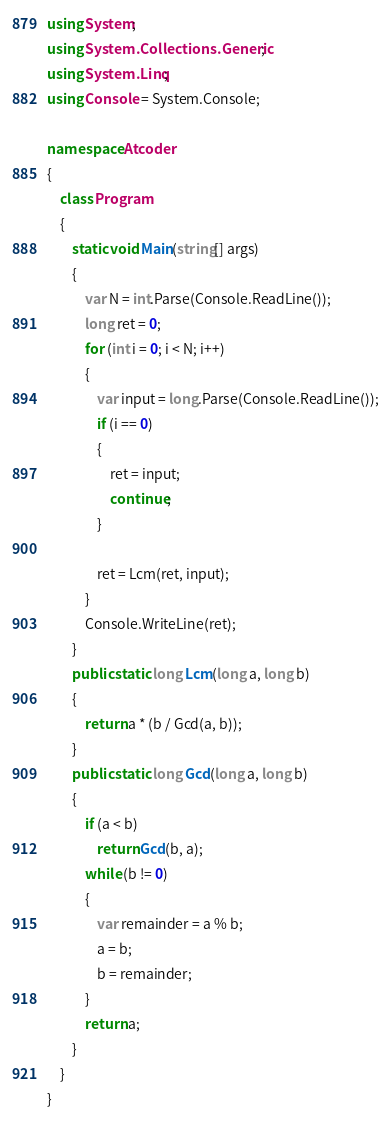<code> <loc_0><loc_0><loc_500><loc_500><_C#_>using System;
using System.Collections.Generic;
using System.Linq;
using Console = System.Console;

namespace Atcoder
{
    class Program
    {
        static void Main(string[] args)
        {
            var N = int.Parse(Console.ReadLine());
            long ret = 0;
            for (int i = 0; i < N; i++)
            {
                var input = long.Parse(Console.ReadLine());
                if (i == 0)
                {
                    ret = input;
                    continue;
                }

                ret = Lcm(ret, input);
            }
            Console.WriteLine(ret);
        }        
        public static long Lcm(long a, long b)
        {
            return a * (b / Gcd(a, b));
        }
        public static long Gcd(long a, long b)
        {
            if (a < b)
                return Gcd(b, a);
            while (b != 0)
            {
                var remainder = a % b;
                a = b;
                b = remainder;
            }
            return a;
        }
    }
}</code> 